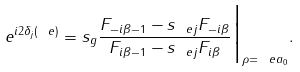<formula> <loc_0><loc_0><loc_500><loc_500>e ^ { i 2 \delta _ { j } ( \ e ) } = s _ { g } \frac { F _ { - i \beta - 1 } - s _ { \ e j } F _ { - i \beta } } { F _ { i \beta - 1 } - s _ { \ e j } F _ { i \beta } } \Big | _ { \rho = \ e a _ { 0 } } .</formula> 